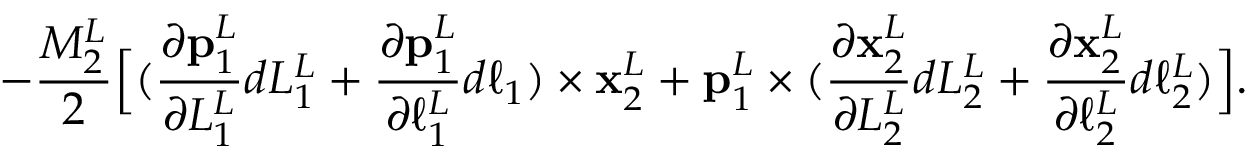<formula> <loc_0><loc_0><loc_500><loc_500>- \frac { M _ { 2 } ^ { L } } { 2 } \left [ ( \frac { \partial p _ { 1 } ^ { L } } { \partial L _ { 1 } ^ { L } } d L _ { 1 } ^ { L } + \frac { \partial p _ { 1 } ^ { L } } { \partial \ell _ { 1 } ^ { L } } d \ell _ { 1 } ) \times x _ { 2 } ^ { L } + p _ { 1 } ^ { L } \times ( \frac { \partial x _ { 2 } ^ { L } } { \partial L _ { 2 } ^ { L } } d L _ { 2 } ^ { L } + \frac { \partial x _ { 2 } ^ { L } } { \partial \ell _ { 2 } ^ { L } } d \ell _ { 2 } ^ { L } ) \right ] .</formula> 